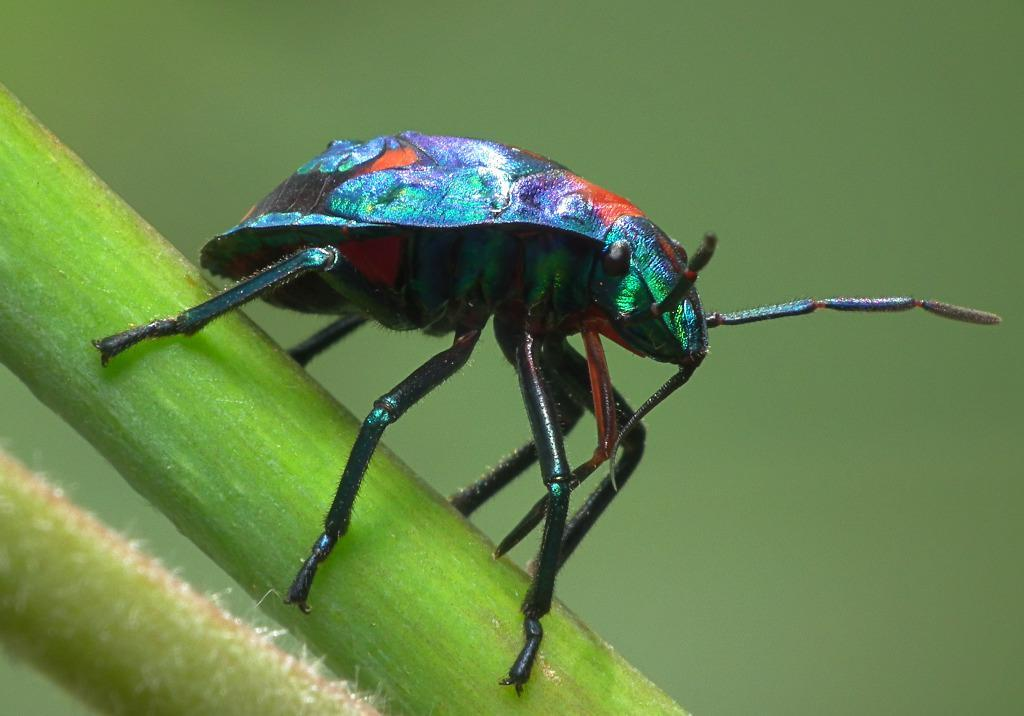What type of creature can be seen in the image? There is an insect in the image. Where is the insect located in relation to the plant? The insect is on the stem of a plant. How many cattle can be seen grazing in the image? There are no cattle present in the image; it features an insect on the stem of a plant. What type of knee is visible in the image? There is no knee present in the image. 